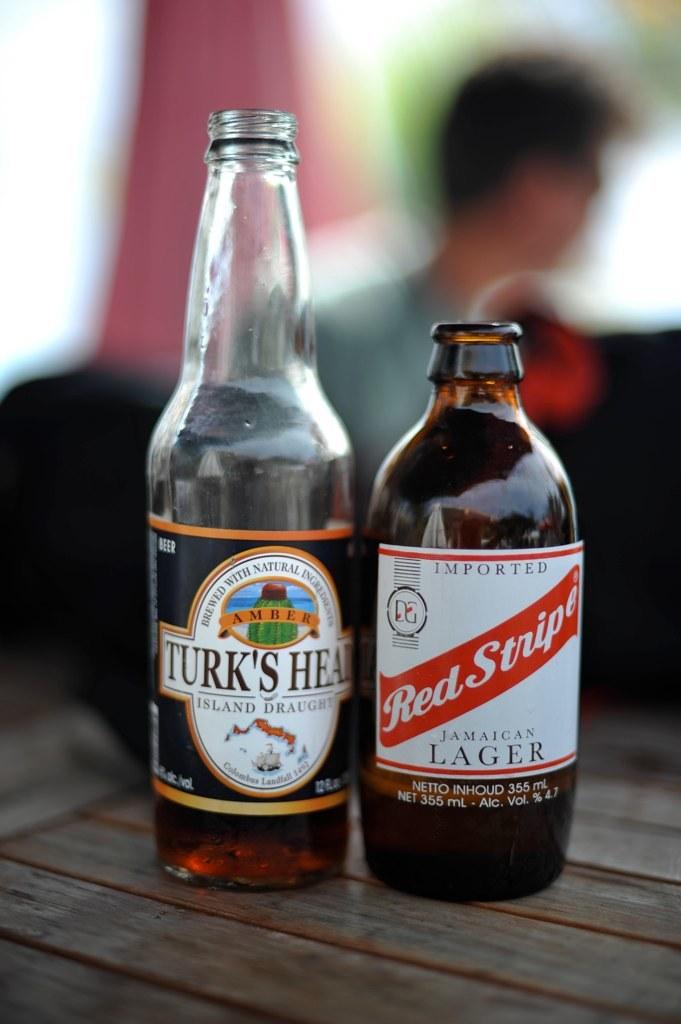What beer is on the right?
Keep it short and to the point. Red stripe. 